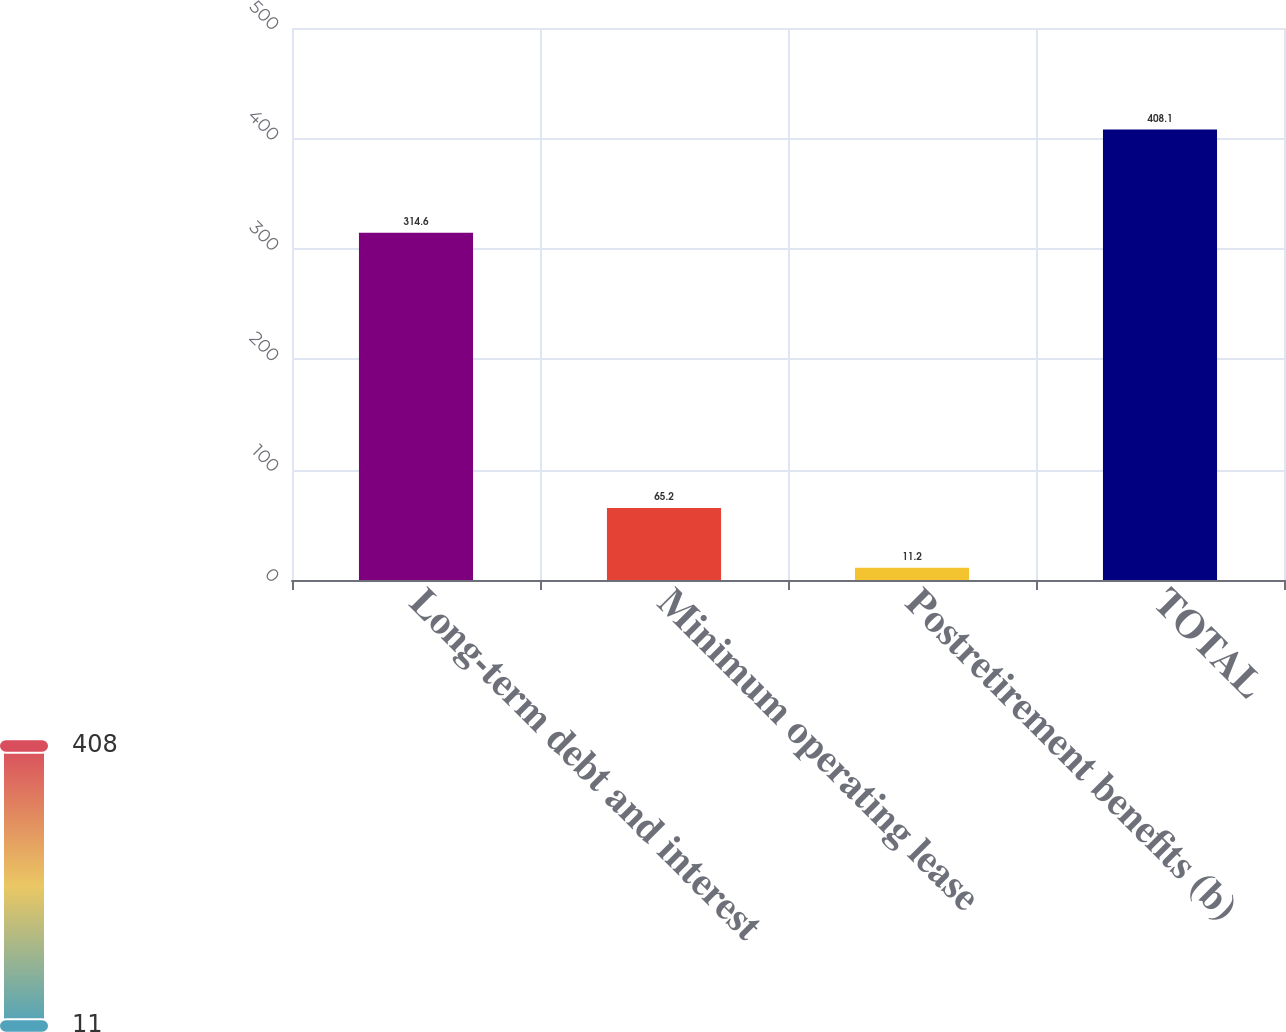Convert chart. <chart><loc_0><loc_0><loc_500><loc_500><bar_chart><fcel>Long-term debt and interest<fcel>Minimum operating lease<fcel>Postretirement benefits (b)<fcel>TOTAL<nl><fcel>314.6<fcel>65.2<fcel>11.2<fcel>408.1<nl></chart> 